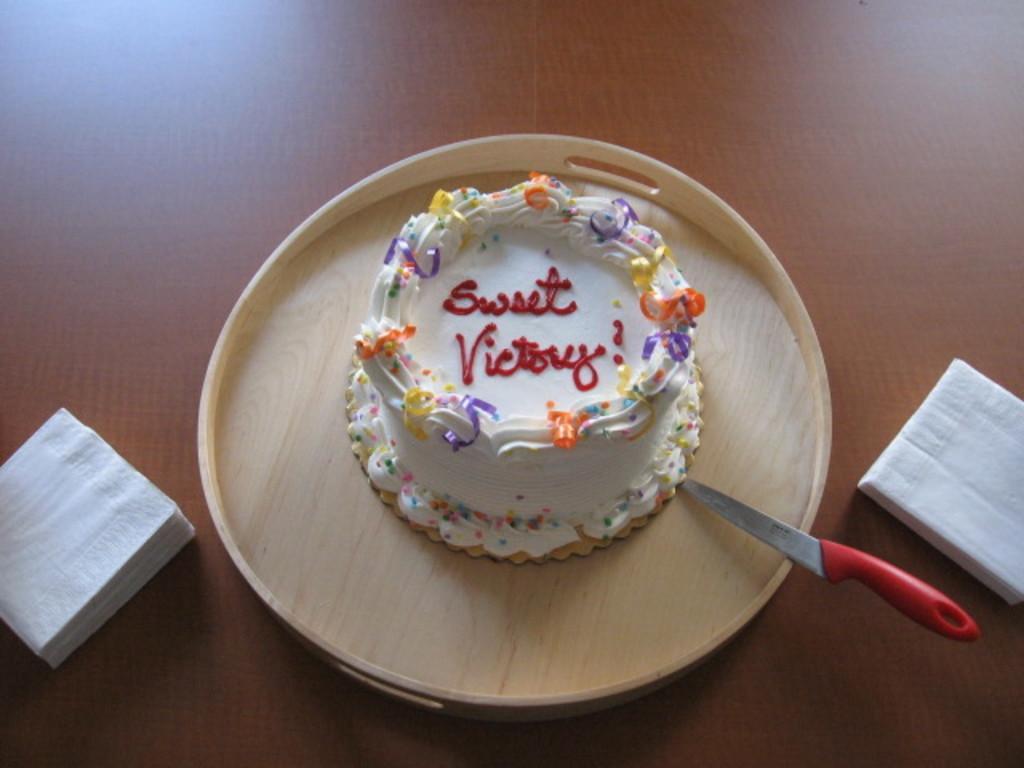Can you describe this image briefly? In this image there is a cake, knife in a plate. Beside the plate there are tissues on the table. 